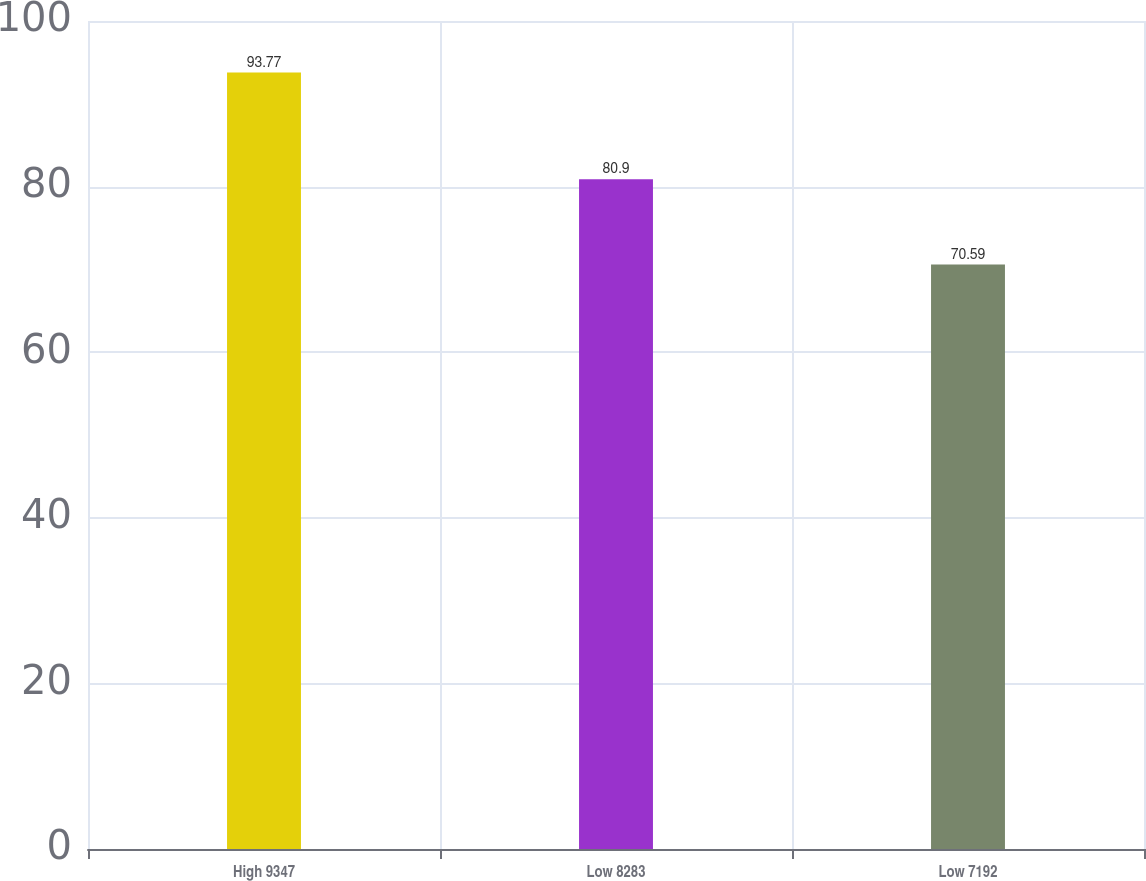Convert chart. <chart><loc_0><loc_0><loc_500><loc_500><bar_chart><fcel>High 9347<fcel>Low 8283<fcel>Low 7192<nl><fcel>93.77<fcel>80.9<fcel>70.59<nl></chart> 